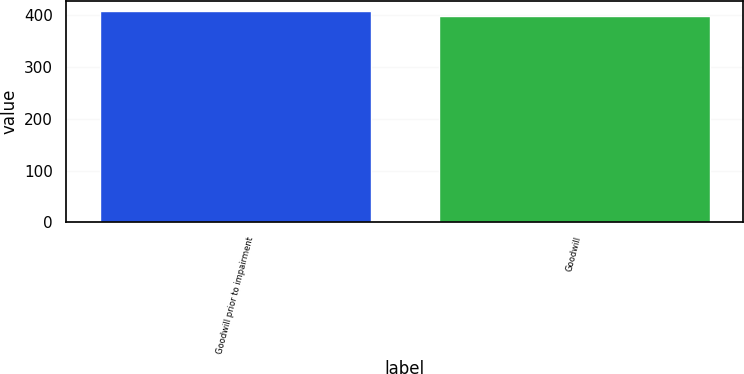Convert chart to OTSL. <chart><loc_0><loc_0><loc_500><loc_500><bar_chart><fcel>Goodwill prior to impairment<fcel>Goodwill<nl><fcel>407.7<fcel>399.1<nl></chart> 